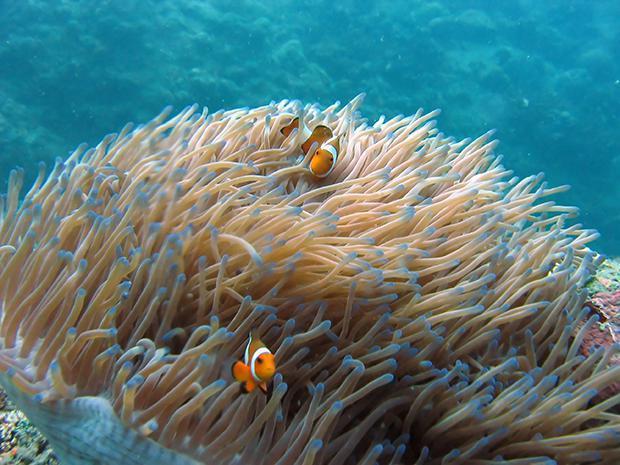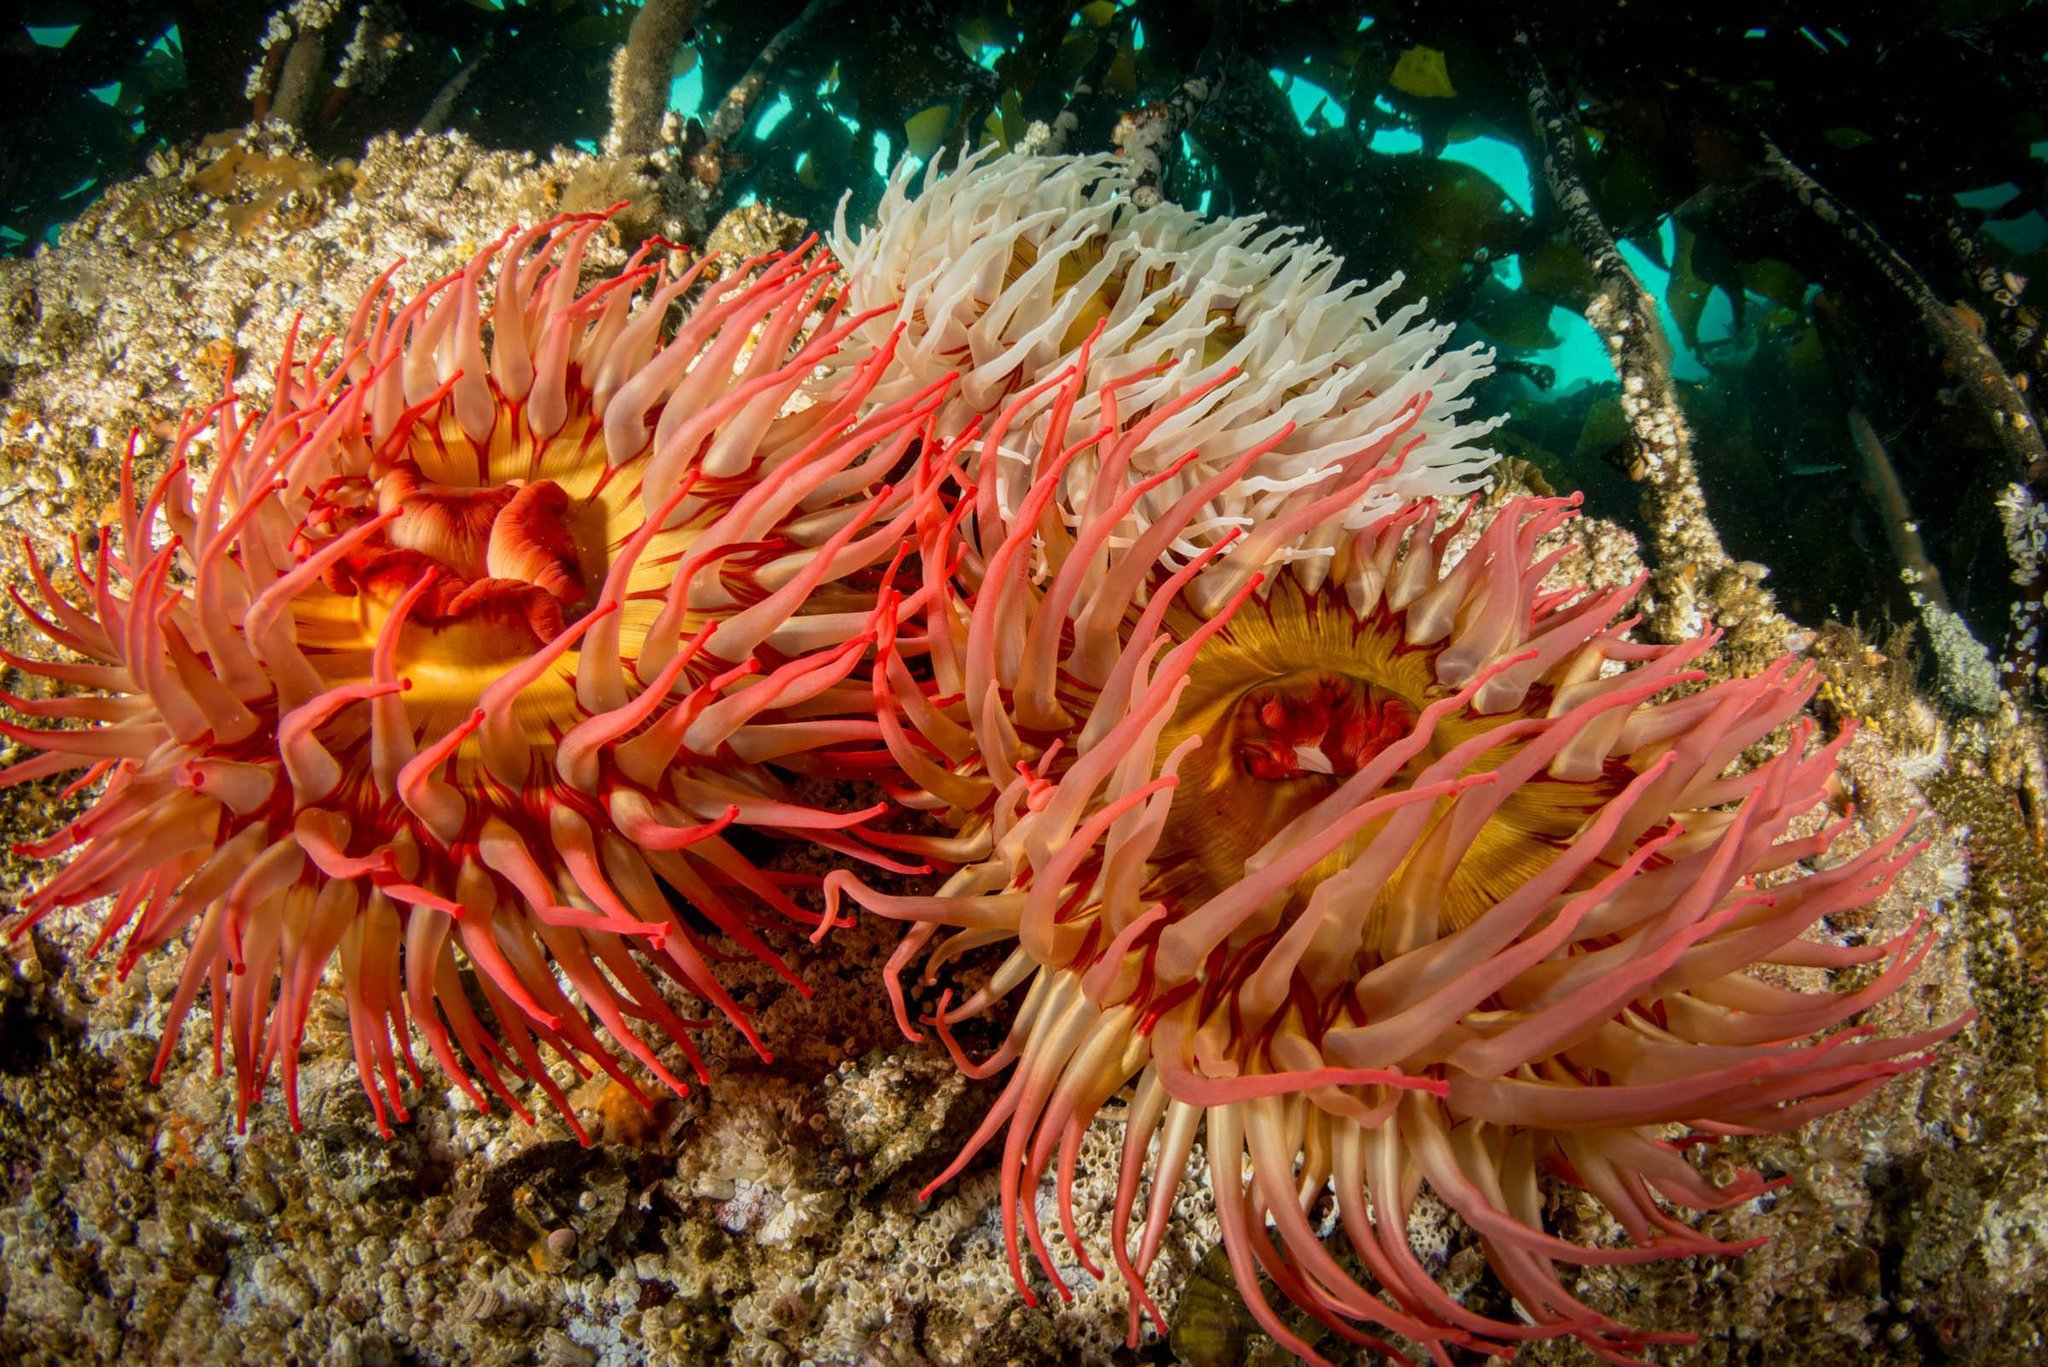The first image is the image on the left, the second image is the image on the right. For the images shown, is this caption "there are 2 fish swimming near the anenome" true? Answer yes or no. Yes. The first image is the image on the left, the second image is the image on the right. Evaluate the accuracy of this statement regarding the images: "In one image, there is at least one fish swimming in or near the sea anemone". Is it true? Answer yes or no. Yes. 